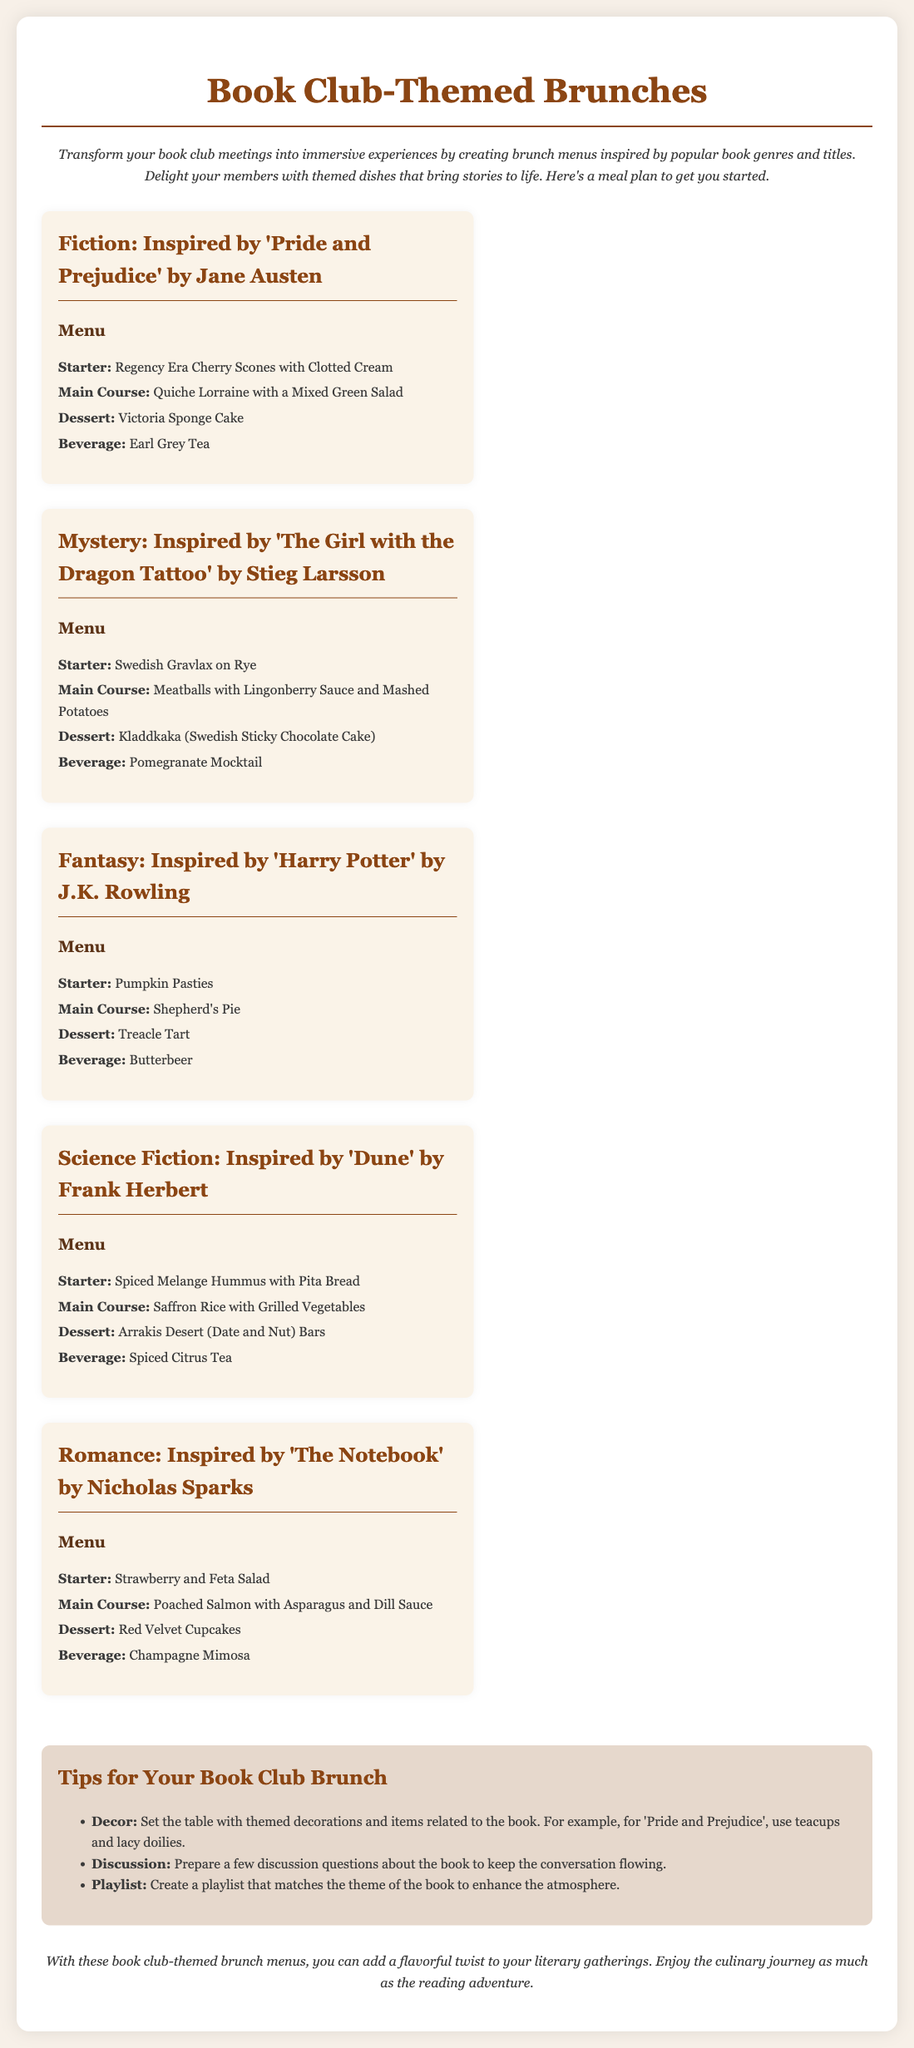What is the title of the document? The title of the document is the main subject presented at the top of the page.
Answer: Book Club-Themed Brunches Which book inspired the Fiction menu? The Fiction menu is inspired by a specific literary work, mentioned explicitly in the menu section.
Answer: Pride and Prejudice What beverage is served with the Fantasy menu? Each menu section includes a beverage item specifically paired with the theme.
Answer: Butterbeer How many menus are included in the meal plan? The document lists different themed menus, and counting them gives the total number.
Answer: Five What dessert is featured in the Romance menu? The document specifies a particular dessert item included in the menu for Romance.
Answer: Red Velvet Cupcakes What starter is offered in the Mystery menu? The first item listed in the Mystery menu is the starter dish.
Answer: Swedish Gravlax on Rye What is one decoration tip mentioned for the book club brunch? The tips section provides advice on decoration.
Answer: Themed decorations Which genre menu includes a dish called Treacle Tart? The dessert in question is associated with a specific genre mentioned in the meal plan.
Answer: Fantasy 